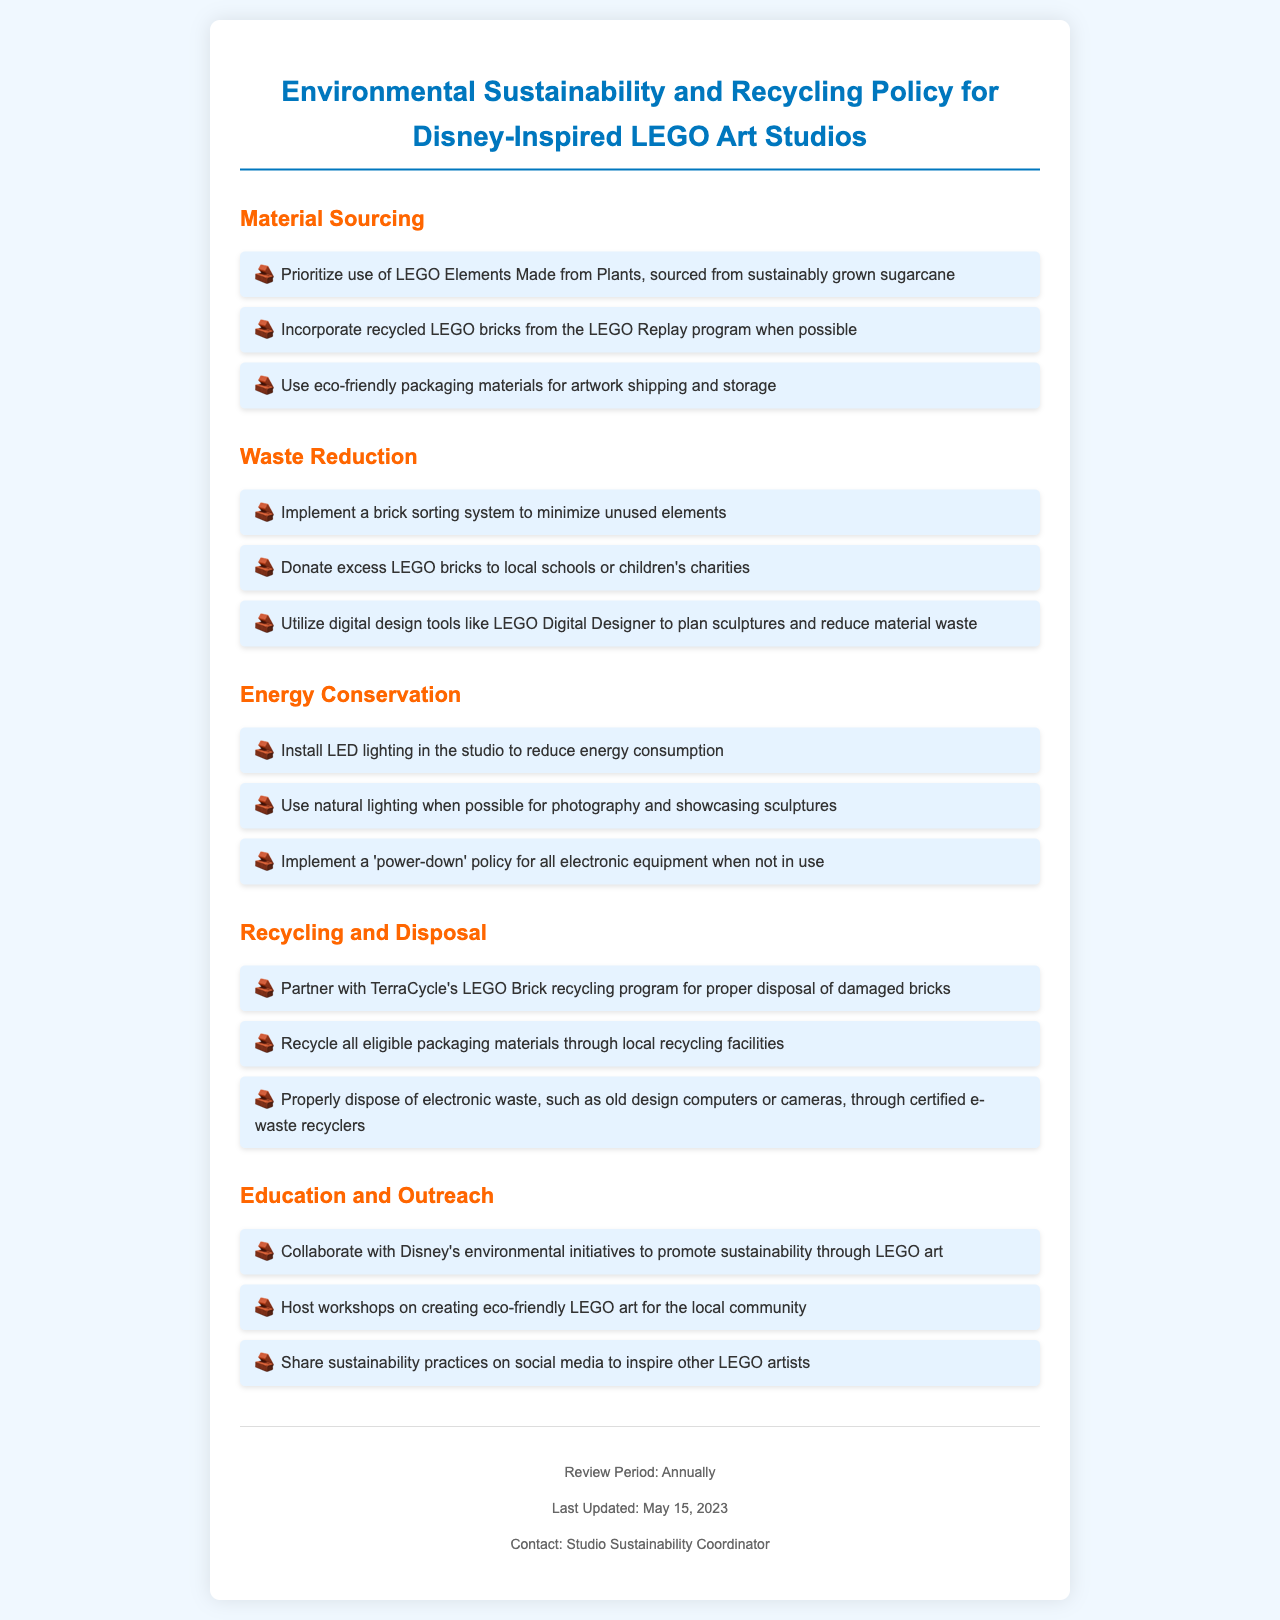What is the title of the document? The title is stated at the top of the document, summarizing its purpose.
Answer: Environmental Sustainability and Recycling Policy for Disney-Inspired LEGO Art Studios What is one source of LEGO elements mentioned? The document specifies the sourcing of LEGO elements made from plants, particularly the material used.
Answer: Sustainably grown sugarcane Which program is used for recycling damaged bricks? This information is found under the Recycling and Disposal section, detailing partnerships for sustainable practices.
Answer: TerraCycle's LEGO Brick recycling program How often is the policy reviewed? The review period is clearly mentioned in the footer of the document, indicating the frequency of updates.
Answer: Annually What kind of lighting is recommended for energy conservation? The energy conservation section specifies types of lighting that should be used within the studio for sustainability.
Answer: LED lighting What is the purpose of the workshops mentioned in the document? The document highlights community engagement efforts through workshops, focusing on specific practices.
Answer: Creating eco-friendly LEGO art Which materials should be used for packaging? This detail is outlined in the Material Sourcing section, addressing environmentally sustainable choices for packaging.
Answer: Eco-friendly packaging materials How should excess LEGO bricks be handled? The Waste Reduction section provides a clear action for excess materials that can be beneficial for community resources.
Answer: Donate to local schools or children's charities 